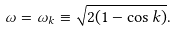Convert formula to latex. <formula><loc_0><loc_0><loc_500><loc_500>\omega = \omega _ { k } \equiv \sqrt { 2 ( 1 - \cos k ) } .</formula> 